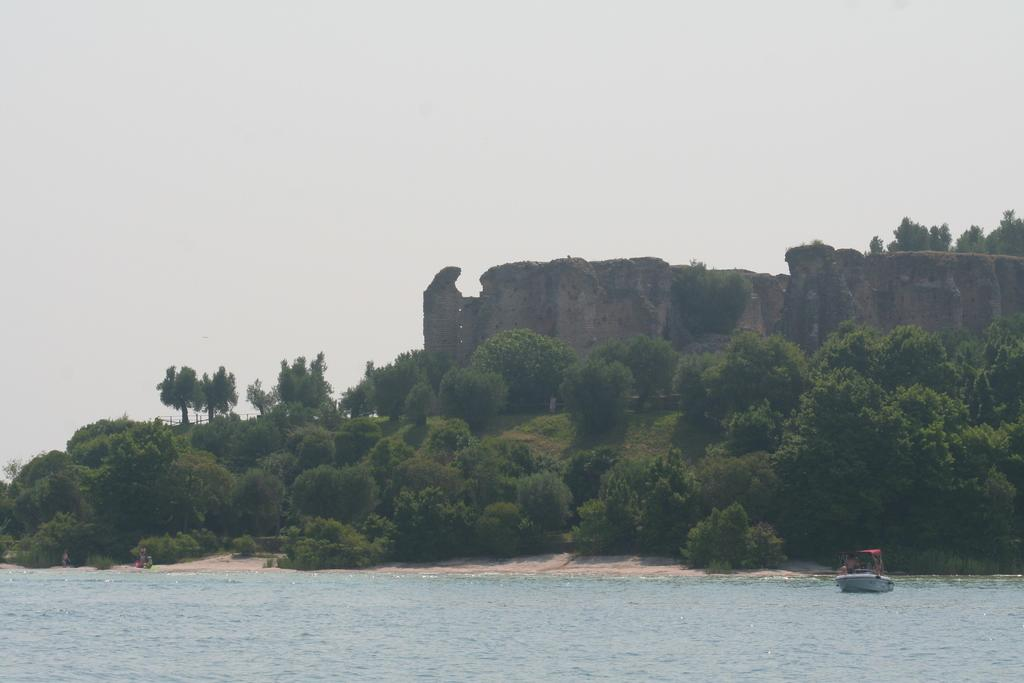What is the main subject of the image? The main subject of the image is a boat. Where is the boat located? The boat is on the water. What can be seen in front of the boat? There are trees and a hill in front of the boat. What is visible in the background of the image? The sky is visible in the image. What type of bit is the boat using to communicate with its partner in the image? There is no bit or communication device present in the image, and there is no indication of a partner for the boat. 